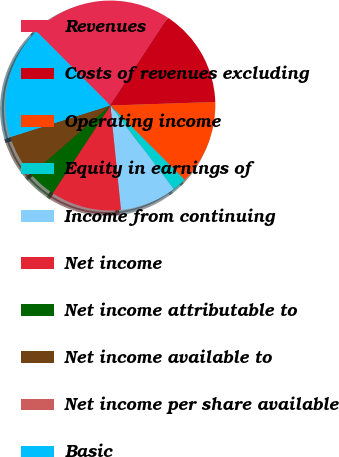<chart> <loc_0><loc_0><loc_500><loc_500><pie_chart><fcel>Revenues<fcel>Costs of revenues excluding<fcel>Operating income<fcel>Equity in earnings of<fcel>Income from continuing<fcel>Net income<fcel>Net income attributable to<fcel>Net income available to<fcel>Net income per share available<fcel>Basic<nl><fcel>21.73%<fcel>15.21%<fcel>13.04%<fcel>2.18%<fcel>8.7%<fcel>10.87%<fcel>4.35%<fcel>6.52%<fcel>0.01%<fcel>17.39%<nl></chart> 